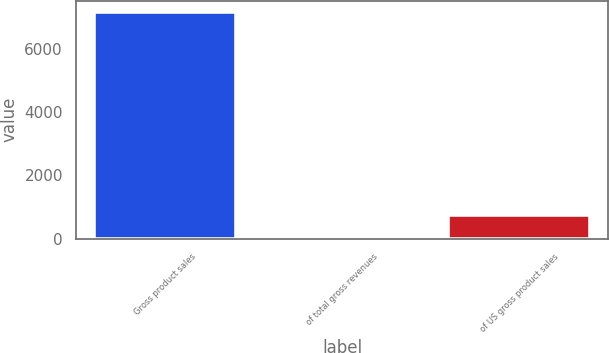<chart> <loc_0><loc_0><loc_500><loc_500><bar_chart><fcel>Gross product sales<fcel>of total gross revenues<fcel>of US gross product sales<nl><fcel>7179<fcel>37<fcel>751.2<nl></chart> 